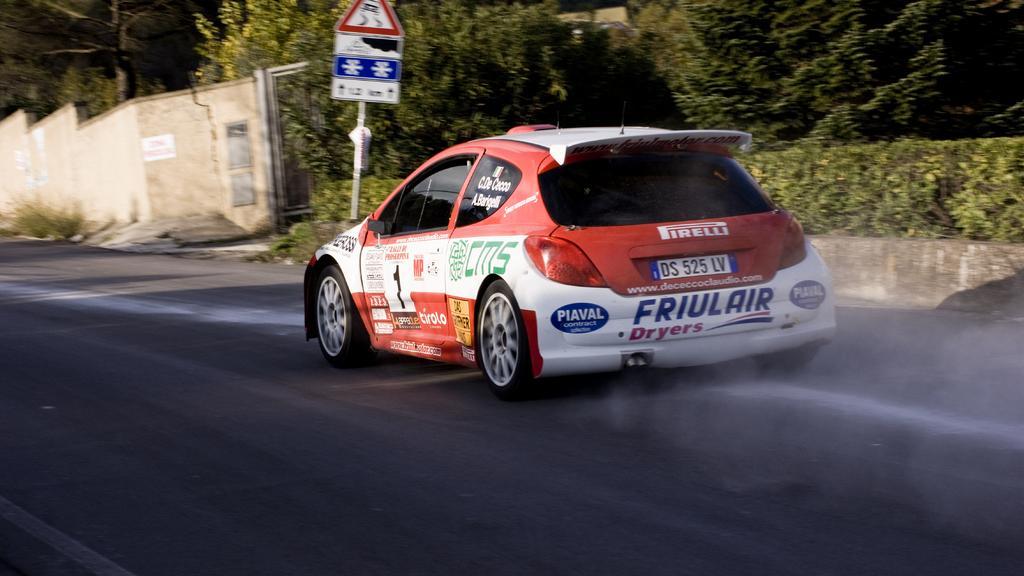Could you give a brief overview of what you see in this image? In this picture I can see a vehicle on the road. I can see a wall, pole with boards, and in the background there are plants and trees. 